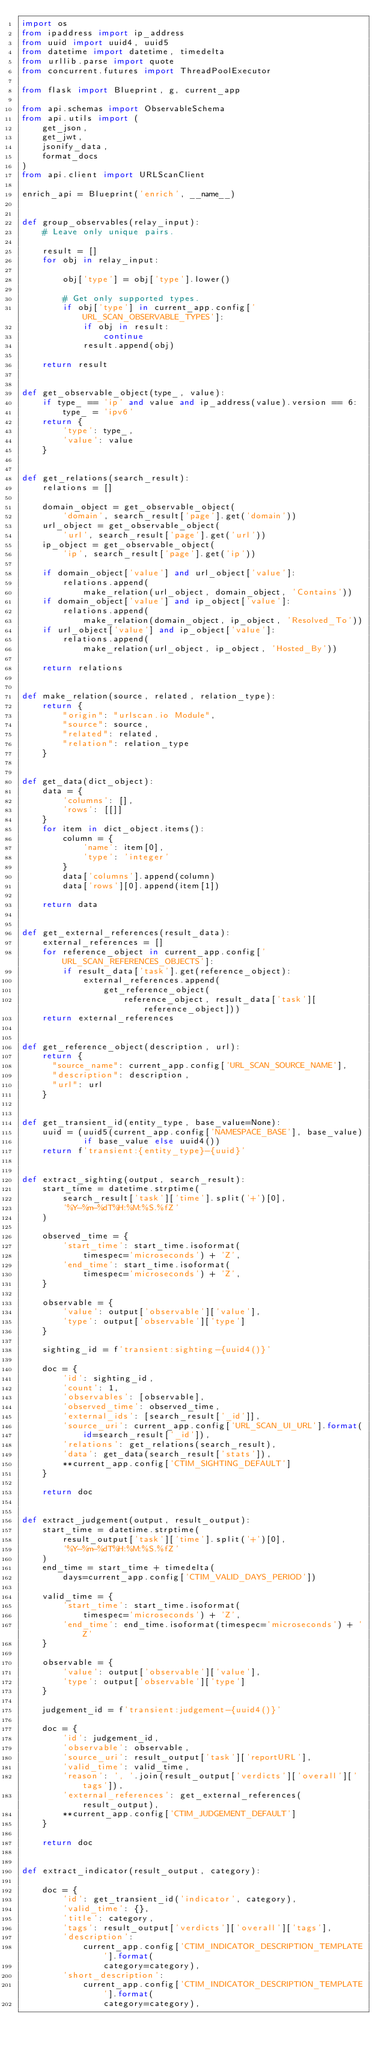Convert code to text. <code><loc_0><loc_0><loc_500><loc_500><_Python_>import os
from ipaddress import ip_address
from uuid import uuid4, uuid5
from datetime import datetime, timedelta
from urllib.parse import quote
from concurrent.futures import ThreadPoolExecutor

from flask import Blueprint, g, current_app

from api.schemas import ObservableSchema
from api.utils import (
    get_json,
    get_jwt,
    jsonify_data,
    format_docs
)
from api.client import URLScanClient

enrich_api = Blueprint('enrich', __name__)


def group_observables(relay_input):
    # Leave only unique pairs.

    result = []
    for obj in relay_input:

        obj['type'] = obj['type'].lower()

        # Get only supported types.
        if obj['type'] in current_app.config['URL_SCAN_OBSERVABLE_TYPES']:
            if obj in result:
                continue
            result.append(obj)

    return result


def get_observable_object(type_, value):
    if type_ == 'ip' and value and ip_address(value).version == 6:
        type_ = 'ipv6'
    return {
        'type': type_,
        'value': value
    }


def get_relations(search_result):
    relations = []

    domain_object = get_observable_object(
        'domain', search_result['page'].get('domain'))
    url_object = get_observable_object(
        'url', search_result['page'].get('url'))
    ip_object = get_observable_object(
        'ip', search_result['page'].get('ip'))

    if domain_object['value'] and url_object['value']:
        relations.append(
            make_relation(url_object, domain_object, 'Contains'))
    if domain_object['value'] and ip_object['value']:
        relations.append(
            make_relation(domain_object, ip_object, 'Resolved_To'))
    if url_object['value'] and ip_object['value']:
        relations.append(
            make_relation(url_object, ip_object, 'Hosted_By'))

    return relations


def make_relation(source, related, relation_type):
    return {
        "origin": "urlscan.io Module",
        "source": source,
        "related": related,
        "relation": relation_type
    }


def get_data(dict_object):
    data = {
        'columns': [],
        'rows': [[]]
    }
    for item in dict_object.items():
        column = {
            'name': item[0],
            'type': 'integer'
        }
        data['columns'].append(column)
        data['rows'][0].append(item[1])

    return data


def get_external_references(result_data):
    external_references = []
    for reference_object in current_app.config['URL_SCAN_REFERENCES_OBJECTS']:
        if result_data['task'].get(reference_object):
            external_references.append(
                get_reference_object(
                    reference_object, result_data['task'][reference_object]))
    return external_references


def get_reference_object(description, url):
    return {
      "source_name": current_app.config['URL_SCAN_SOURCE_NAME'],
      "description": description,
      "url": url
    }


def get_transient_id(entity_type, base_value=None):
    uuid = (uuid5(current_app.config['NAMESPACE_BASE'], base_value)
            if base_value else uuid4())
    return f'transient:{entity_type}-{uuid}'


def extract_sighting(output, search_result):
    start_time = datetime.strptime(
        search_result['task']['time'].split('+')[0],
        '%Y-%m-%dT%H:%M:%S.%fZ'
    )

    observed_time = {
        'start_time': start_time.isoformat(
            timespec='microseconds') + 'Z',
        'end_time': start_time.isoformat(
            timespec='microseconds') + 'Z',
    }

    observable = {
        'value': output['observable']['value'],
        'type': output['observable']['type']
    }

    sighting_id = f'transient:sighting-{uuid4()}'

    doc = {
        'id': sighting_id,
        'count': 1,
        'observables': [observable],
        'observed_time': observed_time,
        'external_ids': [search_result['_id']],
        'source_uri': current_app.config['URL_SCAN_UI_URL'].format(
            id=search_result['_id']),
        'relations': get_relations(search_result),
        'data': get_data(search_result['stats']),
        **current_app.config['CTIM_SIGHTING_DEFAULT']
    }

    return doc


def extract_judgement(output, result_output):
    start_time = datetime.strptime(
        result_output['task']['time'].split('+')[0],
        '%Y-%m-%dT%H:%M:%S.%fZ'
    )
    end_time = start_time + timedelta(
        days=current_app.config['CTIM_VALID_DAYS_PERIOD'])

    valid_time = {
        'start_time': start_time.isoformat(
            timespec='microseconds') + 'Z',
        'end_time': end_time.isoformat(timespec='microseconds') + 'Z'
    }

    observable = {
        'value': output['observable']['value'],
        'type': output['observable']['type']
    }

    judgement_id = f'transient:judgement-{uuid4()}'

    doc = {
        'id': judgement_id,
        'observable': observable,
        'source_uri': result_output['task']['reportURL'],
        'valid_time': valid_time,
        'reason': ', '.join(result_output['verdicts']['overall']['tags']),
        'external_references': get_external_references(result_output),
        **current_app.config['CTIM_JUDGEMENT_DEFAULT']
    }

    return doc


def extract_indicator(result_output, category):

    doc = {
        'id': get_transient_id('indicator', category),
        'valid_time': {},
        'title': category,
        'tags': result_output['verdicts']['overall']['tags'],
        'description':
            current_app.config['CTIM_INDICATOR_DESCRIPTION_TEMPLATE'].format(
                category=category),
        'short_description':
            current_app.config['CTIM_INDICATOR_DESCRIPTION_TEMPLATE'].format(
                category=category),</code> 